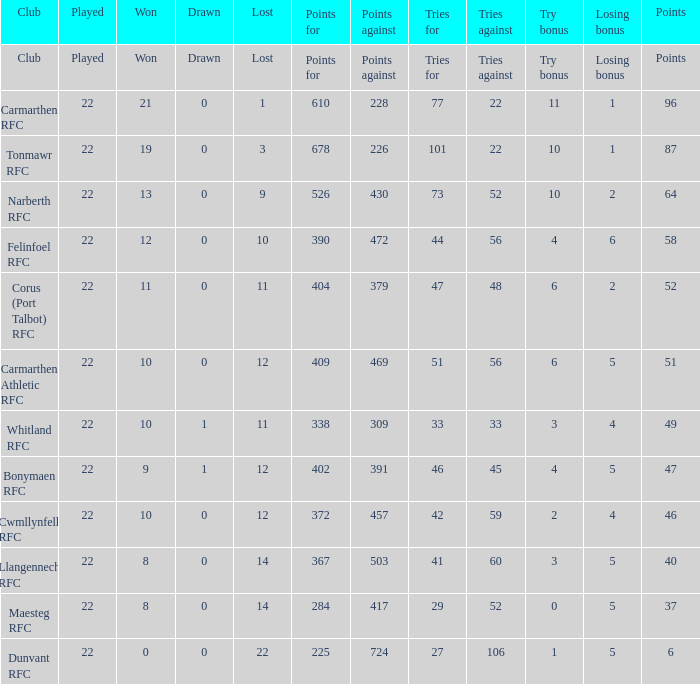Specify the losing incentive for 2 5.0. 